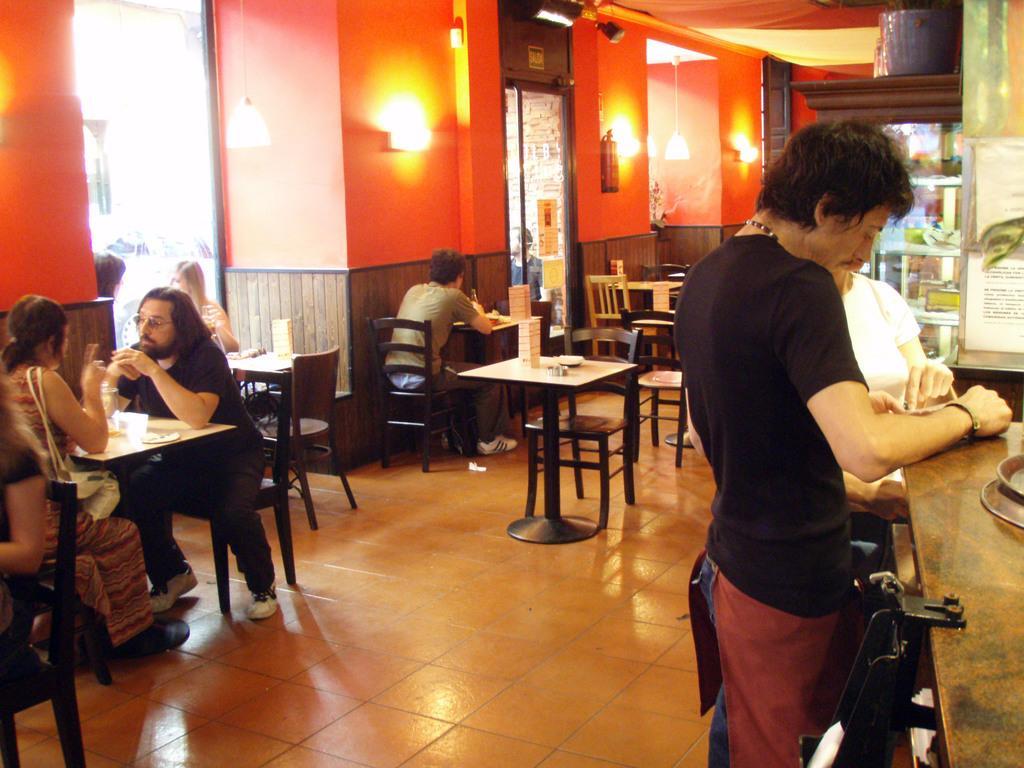How would you summarize this image in a sentence or two? In the left bottom, there are four persons sitting on the chair in front of the table and talking. In the middle, one person is sitting on the chair. In the right, there are two persons standing in front of the table. The walls are of orange in color on which chandelier is hanged. This image is taken inside a restaurant. 